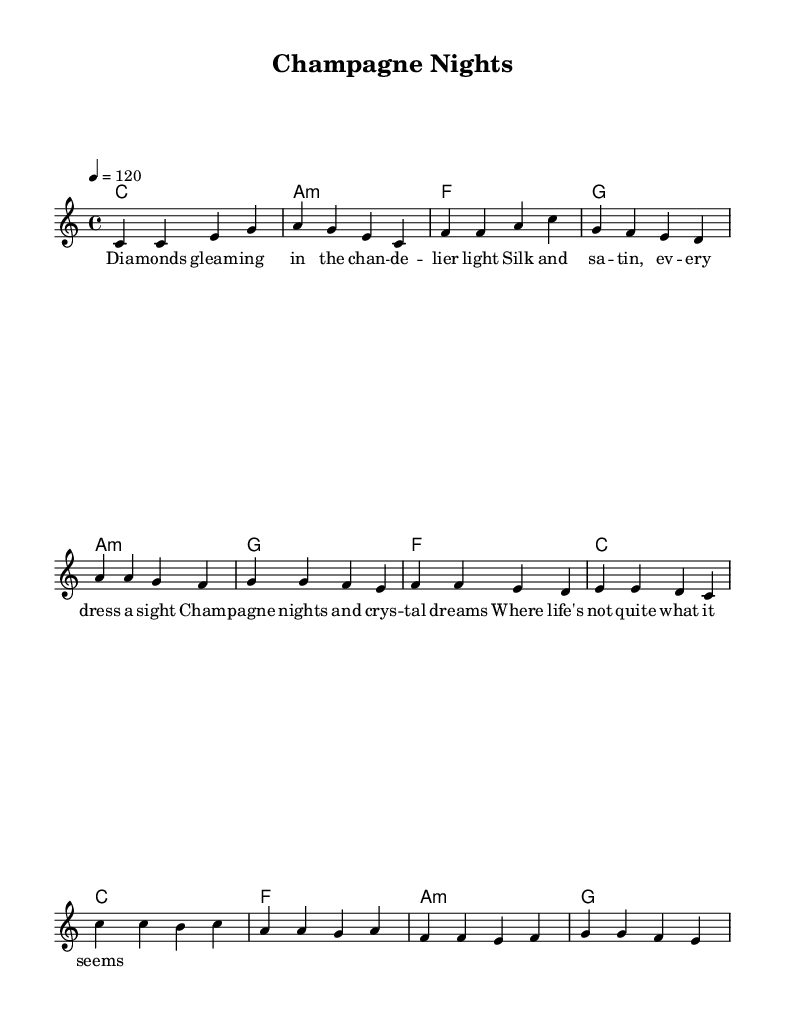What is the key signature of this music? The key signature is C major, which has no sharps or flats.
Answer: C major What is the time signature of this music? The time signature is indicated as 4/4, meaning there are four beats in each measure.
Answer: 4/4 What is the tempo marking for this piece? The tempo is marked as quarter note equals 120, which indicates a moderately fast tempo.
Answer: 120 How many measures are in the verse? Counting the measures written in the verse section, there are 4 measures total.
Answer: 4 Which section comes after the verse in this song structure? The music structure indicates that the prechorus follows the verse.
Answer: Prechorus What is the primary theme of the lyrics in the chorus? The lyrics in the chorus focus on glamorous nightlife and dreams associated with high-society events.
Answer: Glamorous nightlife What type of harmony is used in this piece? The harmony consists of both major and minor chords, primarily utilizing the I, vi, IV, and V chords typical in pop music.
Answer: Major and minor chords 